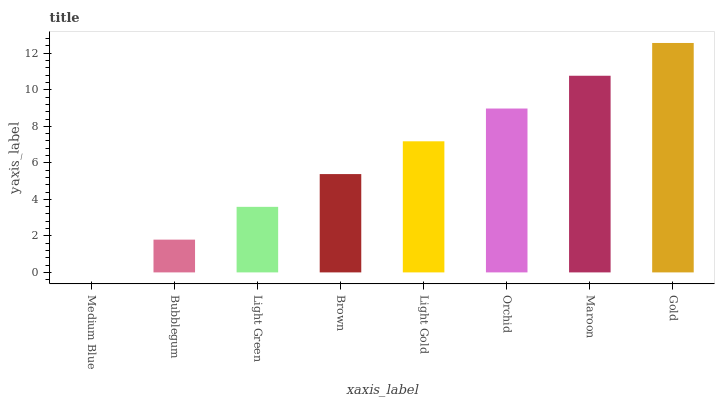Is Bubblegum the minimum?
Answer yes or no. No. Is Bubblegum the maximum?
Answer yes or no. No. Is Bubblegum greater than Medium Blue?
Answer yes or no. Yes. Is Medium Blue less than Bubblegum?
Answer yes or no. Yes. Is Medium Blue greater than Bubblegum?
Answer yes or no. No. Is Bubblegum less than Medium Blue?
Answer yes or no. No. Is Light Gold the high median?
Answer yes or no. Yes. Is Brown the low median?
Answer yes or no. Yes. Is Bubblegum the high median?
Answer yes or no. No. Is Light Gold the low median?
Answer yes or no. No. 